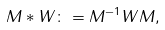<formula> <loc_0><loc_0><loc_500><loc_500>M \ast W \colon = M ^ { - 1 } W M ,</formula> 